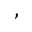<formula> <loc_0><loc_0><loc_500><loc_500>\begin{array} { r l } \end{array} ,</formula> 